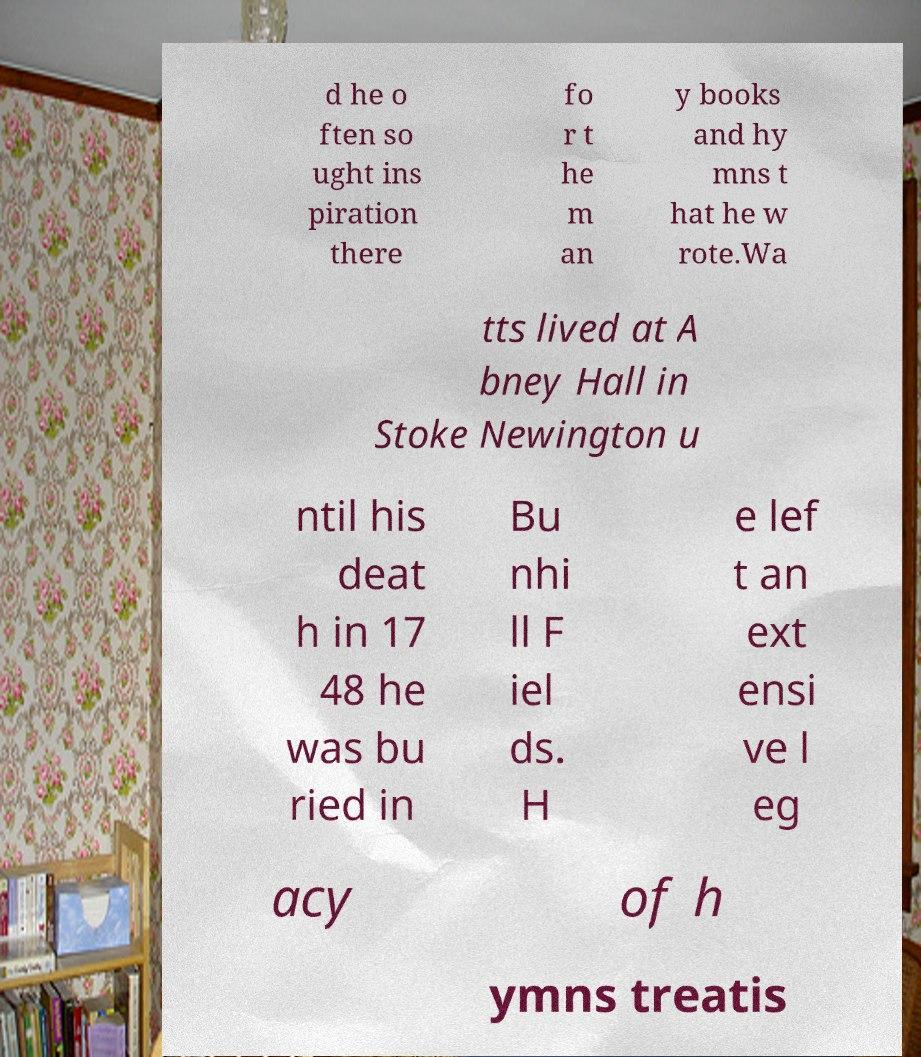Can you read and provide the text displayed in the image?This photo seems to have some interesting text. Can you extract and type it out for me? d he o ften so ught ins piration there fo r t he m an y books and hy mns t hat he w rote.Wa tts lived at A bney Hall in Stoke Newington u ntil his deat h in 17 48 he was bu ried in Bu nhi ll F iel ds. H e lef t an ext ensi ve l eg acy of h ymns treatis 